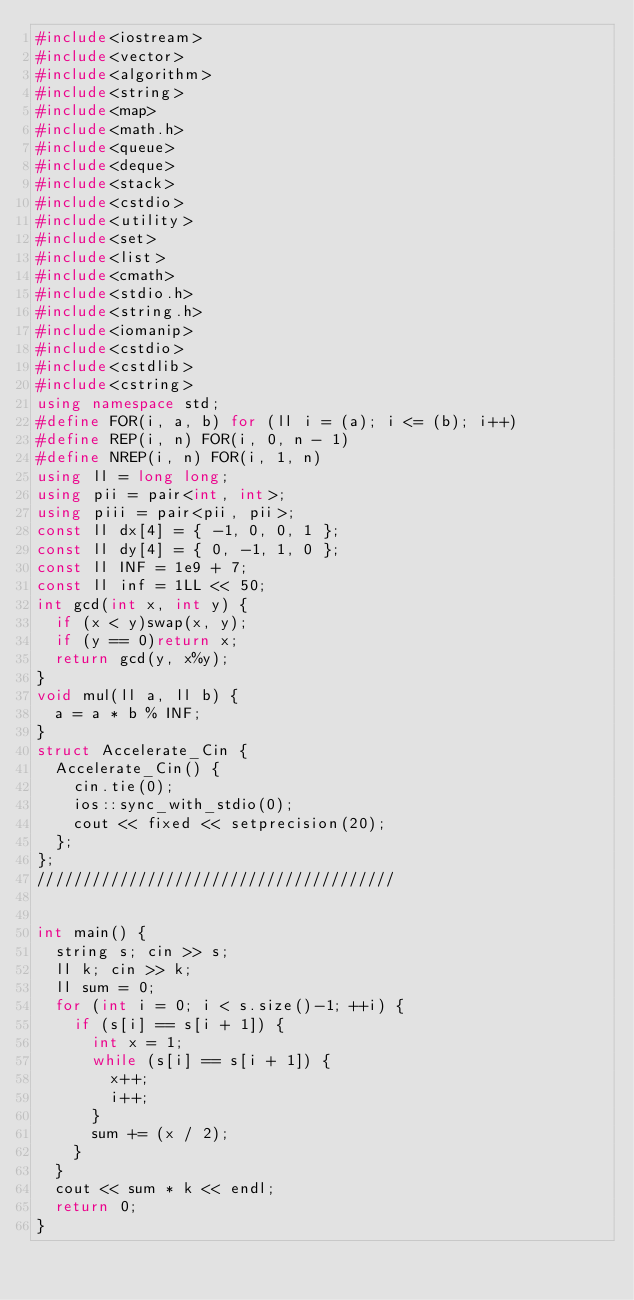<code> <loc_0><loc_0><loc_500><loc_500><_C++_>#include<iostream>
#include<vector>
#include<algorithm>
#include<string>
#include<map>
#include<math.h>
#include<queue>
#include<deque>
#include<stack>
#include<cstdio>
#include<utility>
#include<set>
#include<list>
#include<cmath>
#include<stdio.h>
#include<string.h>
#include<iomanip>
#include<cstdio>
#include<cstdlib>
#include<cstring>
using namespace std;
#define FOR(i, a, b) for (ll i = (a); i <= (b); i++)
#define REP(i, n) FOR(i, 0, n - 1)
#define NREP(i, n) FOR(i, 1, n)
using ll = long long;
using pii = pair<int, int>;
using piii = pair<pii, pii>;
const ll dx[4] = { -1, 0, 0, 1 };
const ll dy[4] = { 0, -1, 1, 0 };
const ll INF = 1e9 + 7;
const ll inf = 1LL << 50;
int gcd(int x, int y) {
	if (x < y)swap(x, y);
	if (y == 0)return x;
	return gcd(y, x%y);
}
void mul(ll a, ll b) {
	a = a * b % INF;
}
struct Accelerate_Cin {
	Accelerate_Cin() {
		cin.tie(0);
		ios::sync_with_stdio(0);
		cout << fixed << setprecision(20);
	};
};
///////////////////////////////////////


int main() {
	string s; cin >> s;
	ll k; cin >> k;
	ll sum = 0;
	for (int i = 0; i < s.size()-1; ++i) {
		if (s[i] == s[i + 1]) {
			int x = 1;
			while (s[i] == s[i + 1]) {
				x++;
				i++;
			}
			sum += (x / 2);
		}
	}
	cout << sum * k << endl;
	return 0;
}
</code> 